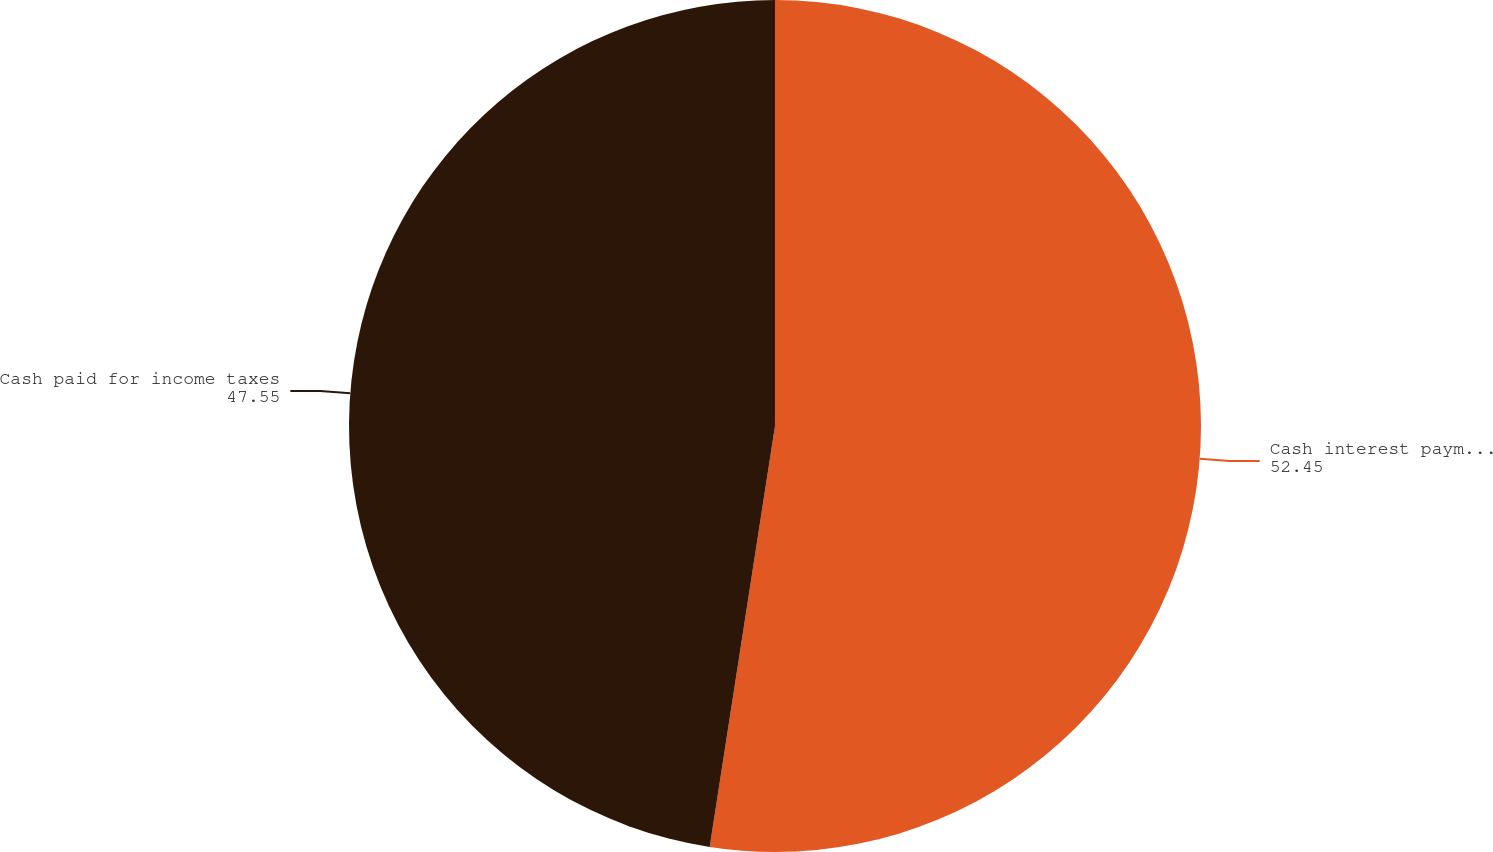Convert chart to OTSL. <chart><loc_0><loc_0><loc_500><loc_500><pie_chart><fcel>Cash interest payments<fcel>Cash paid for income taxes<nl><fcel>52.45%<fcel>47.55%<nl></chart> 